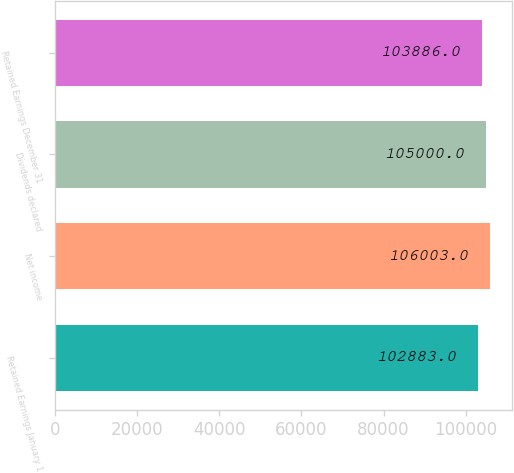Convert chart to OTSL. <chart><loc_0><loc_0><loc_500><loc_500><bar_chart><fcel>Retained Earnings January 1<fcel>Net income<fcel>Dividends declared<fcel>Retained Earnings December 31<nl><fcel>102883<fcel>106003<fcel>105000<fcel>103886<nl></chart> 